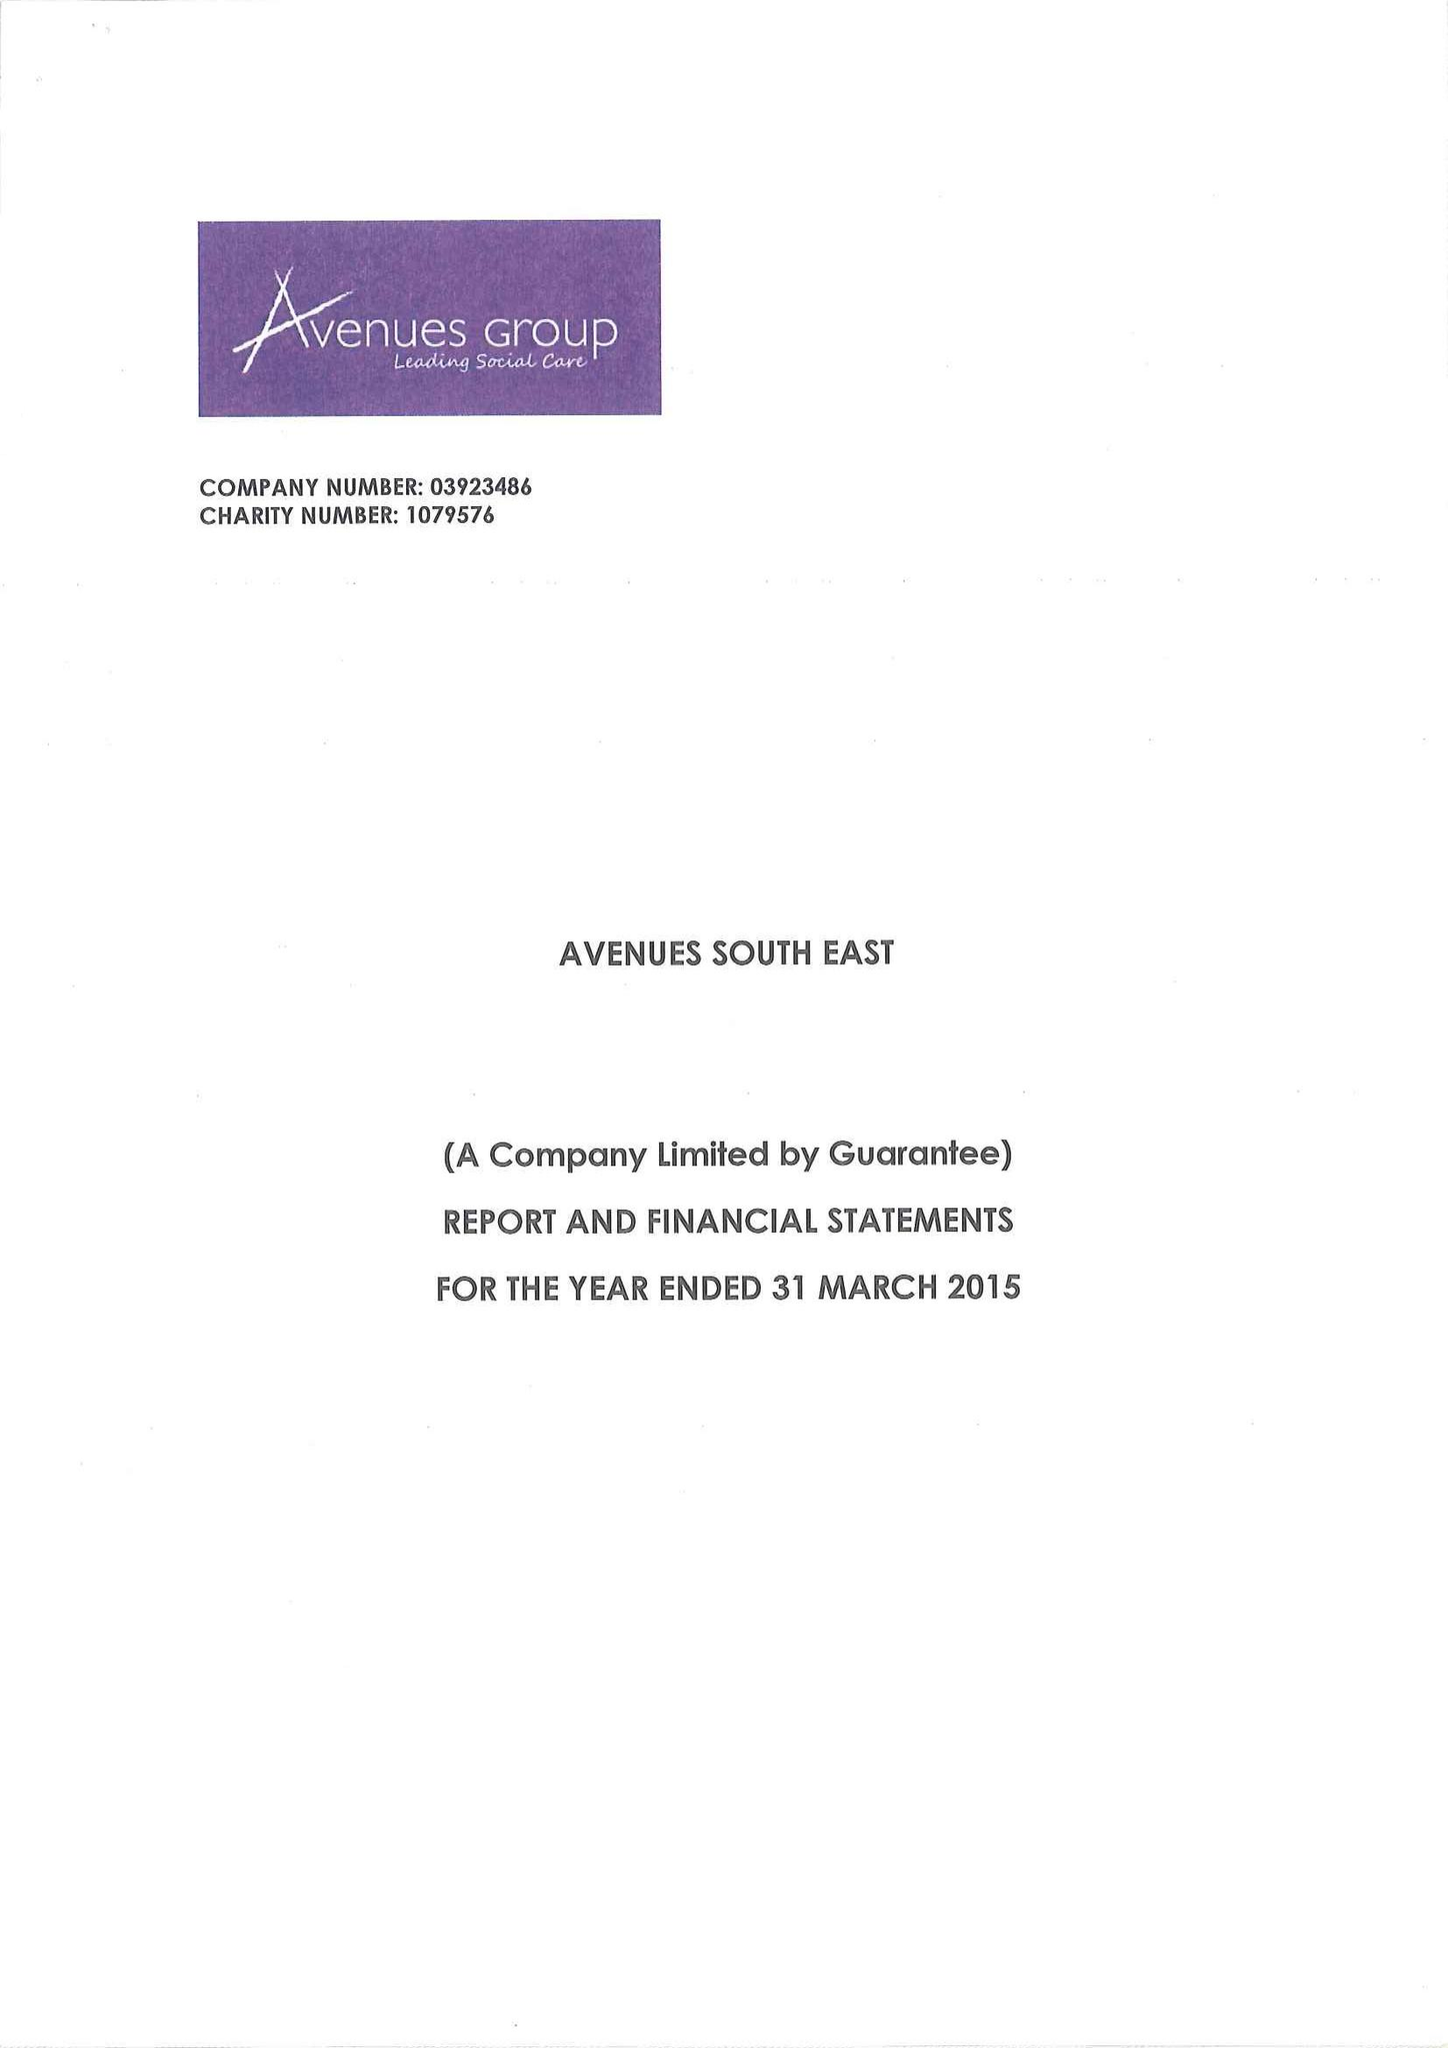What is the value for the report_date?
Answer the question using a single word or phrase. 2015-03-31 